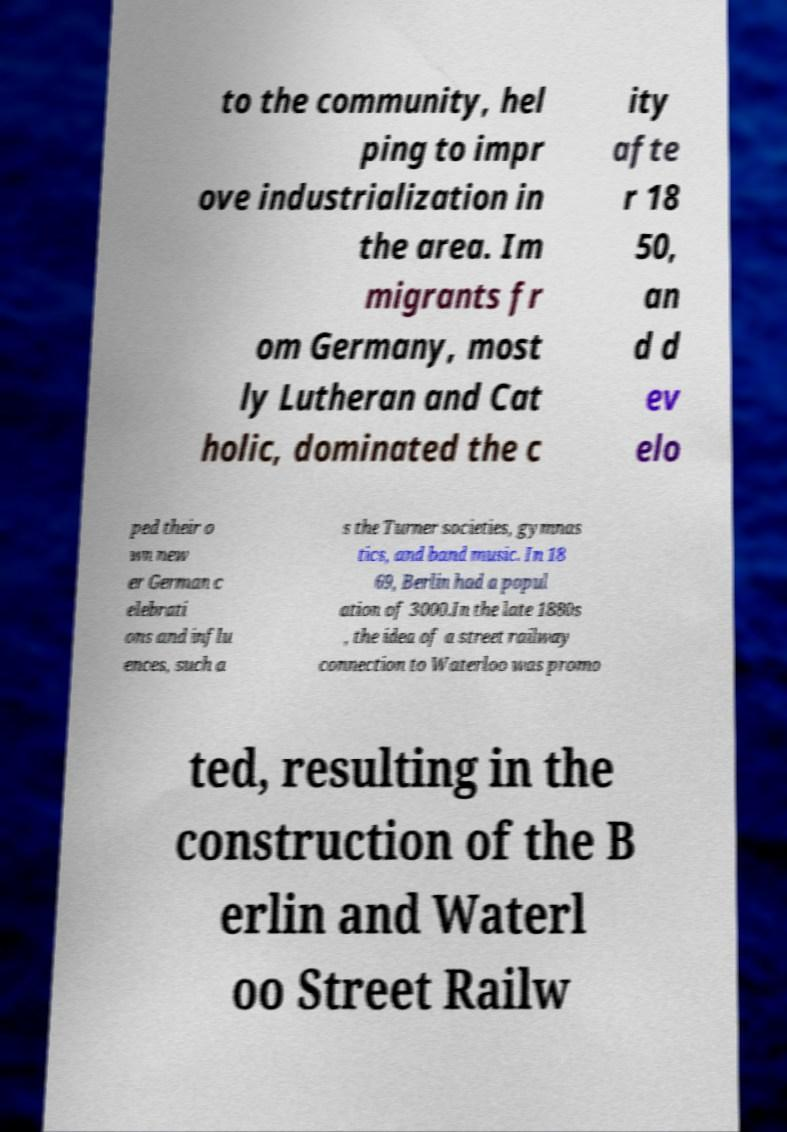What messages or text are displayed in this image? I need them in a readable, typed format. to the community, hel ping to impr ove industrialization in the area. Im migrants fr om Germany, most ly Lutheran and Cat holic, dominated the c ity afte r 18 50, an d d ev elo ped their o wn new er German c elebrati ons and influ ences, such a s the Turner societies, gymnas tics, and band music. In 18 69, Berlin had a popul ation of 3000.In the late 1880s , the idea of a street railway connection to Waterloo was promo ted, resulting in the construction of the B erlin and Waterl oo Street Railw 